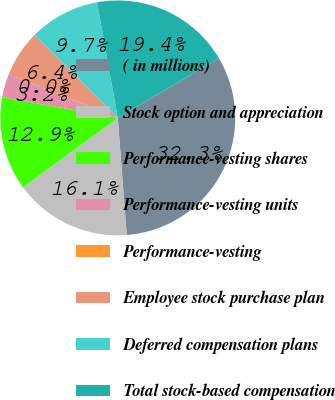Convert chart to OTSL. <chart><loc_0><loc_0><loc_500><loc_500><pie_chart><fcel>( in millions)<fcel>Stock option and appreciation<fcel>Performance-vesting shares<fcel>Performance-vesting units<fcel>Performance-vesting<fcel>Employee stock purchase plan<fcel>Deferred compensation plans<fcel>Total stock-based compensation<nl><fcel>32.26%<fcel>16.13%<fcel>12.9%<fcel>3.23%<fcel>0.0%<fcel>6.45%<fcel>9.68%<fcel>19.35%<nl></chart> 